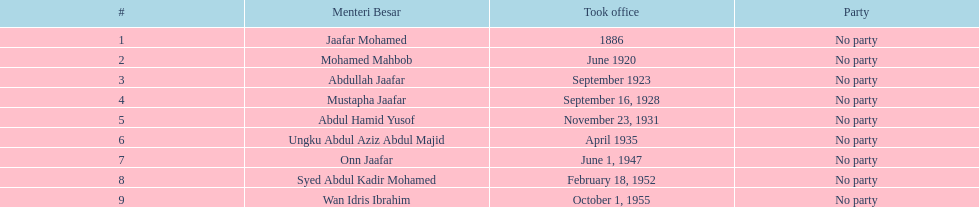Who spend the most amount of time in office? Ungku Abdul Aziz Abdul Majid. 